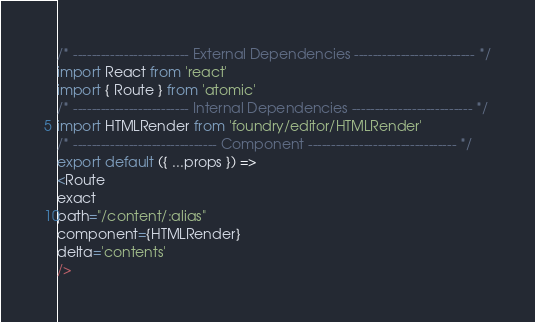<code> <loc_0><loc_0><loc_500><loc_500><_JavaScript_>/* ------------------------- External Dependencies -------------------------- */
import React from 'react'
import { Route } from 'atomic'
/* ------------------------- Internal Dependencies -------------------------- */
import HTMLRender from 'foundry/editor/HTMLRender'
/* ------------------------------- Component -------------------------------- */
export default ({ ...props }) => 
<Route
exact
path="/content/:alias"
component={HTMLRender} 
delta='contents'
/></code> 